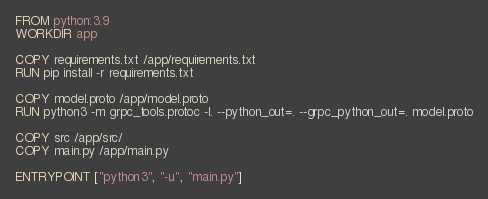<code> <loc_0><loc_0><loc_500><loc_500><_Dockerfile_>FROM python:3.9
WORKDIR app

COPY requirements.txt /app/requirements.txt
RUN pip install -r requirements.txt

COPY model.proto /app/model.proto
RUN python3 -m grpc_tools.protoc -I. --python_out=. --grpc_python_out=. model.proto

COPY src /app/src/
COPY main.py /app/main.py

ENTRYPOINT ["python3", "-u", "main.py"]</code> 